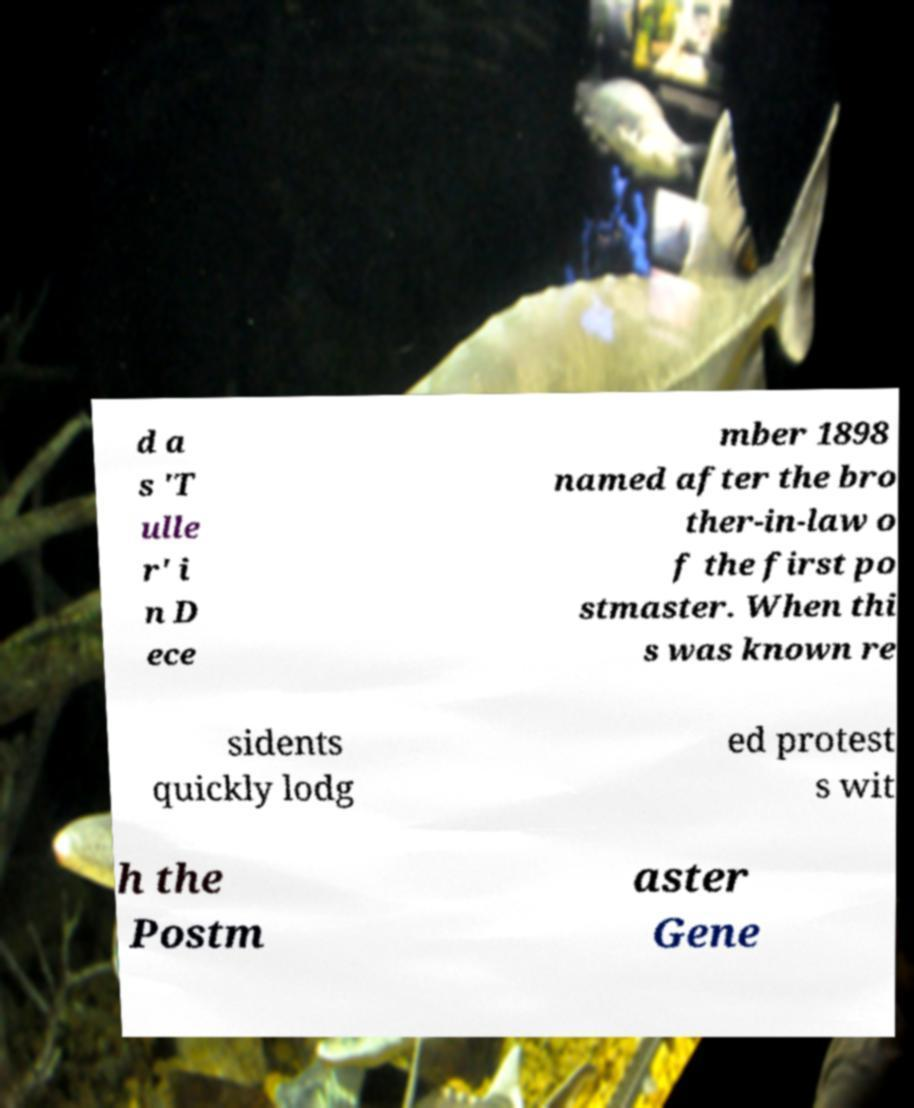Can you accurately transcribe the text from the provided image for me? d a s 'T ulle r' i n D ece mber 1898 named after the bro ther-in-law o f the first po stmaster. When thi s was known re sidents quickly lodg ed protest s wit h the Postm aster Gene 